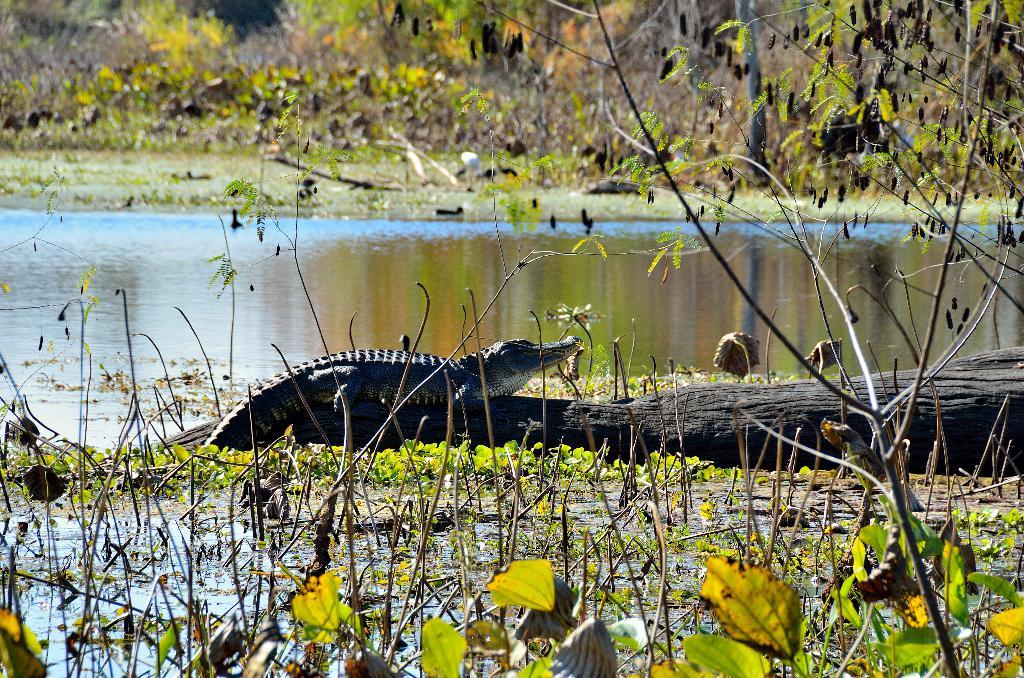What animal is the main subject of the image? There is a crocodile in the image. Where is the crocodile located? The crocodile is on a tree trunk. What type of vegetation can be seen in the image? There are plants in the image. What can be seen in the background of the image? There are trees in the background of the image. What else is visible in the image besides the crocodile and plants? There is water visible in the image. What type of locket is the crocodile holding in the image? There is no locket present in the image; the crocodile is on a tree trunk. What kind of cheese can be seen on the tree trunk in the image? There is no cheese present in the image; the crocodile is on a tree trunk. 